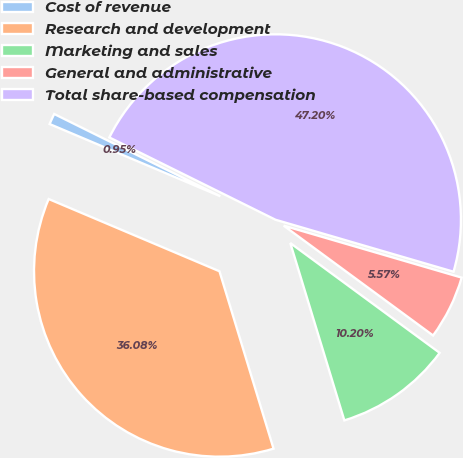<chart> <loc_0><loc_0><loc_500><loc_500><pie_chart><fcel>Cost of revenue<fcel>Research and development<fcel>Marketing and sales<fcel>General and administrative<fcel>Total share-based compensation<nl><fcel>0.95%<fcel>36.08%<fcel>10.2%<fcel>5.57%<fcel>47.2%<nl></chart> 